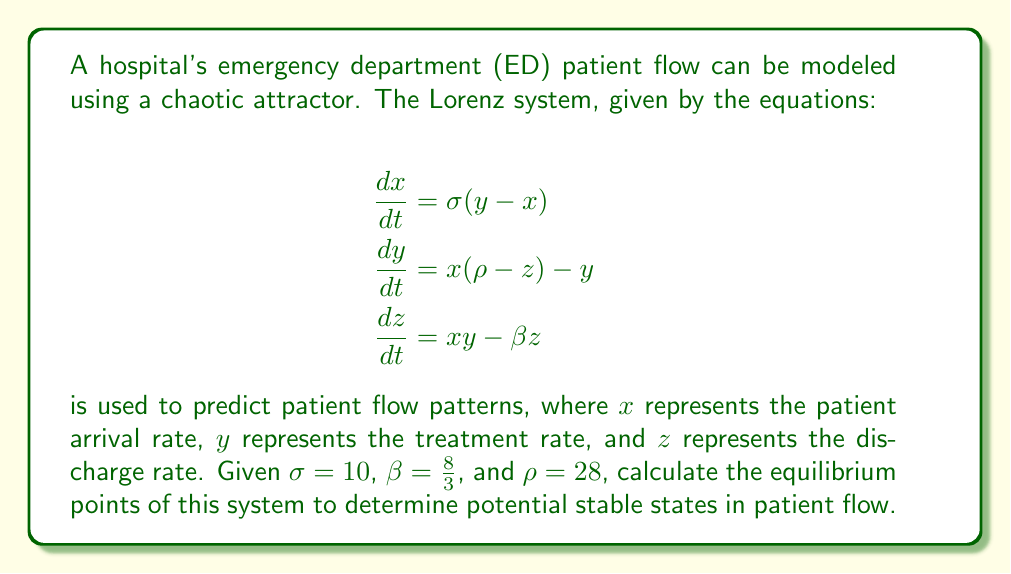Show me your answer to this math problem. To find the equilibrium points, we set all derivatives to zero:

1) $\frac{dx}{dt} = 0$: $\sigma(y - x) = 0$
   This implies $y = x$

2) $\frac{dy}{dt} = 0$: $x(\rho - z) - y = 0$
   Substituting $y = x$: $x(\rho - z) - x = 0$
   $x(\rho - z - 1) = 0$

3) $\frac{dz}{dt} = 0$: $xy - \beta z = 0$
   Substituting $y = x$: $x^2 - \beta z = 0$

From step 2, we have two possibilities:
a) $x = 0$, or
b) $\rho - z - 1 = 0$

Case a) $x = 0$:
If $x = 0$, then $y = 0$ (from step 1), and $z = 0$ (from step 3).
This gives us the first equilibrium point: $(0, 0, 0)$

Case b) $\rho - z - 1 = 0$:
$z = \rho - 1 = 27$

From step 3: $x^2 = \beta z = \frac{8}{3} \cdot 27 = 72$
$x = \pm \sqrt{72} = \pm 6\sqrt{2}$

Since $y = x$, we have two more equilibrium points:
$(\sqrt{72}, \sqrt{72}, 27)$ and $(-\sqrt{72}, -\sqrt{72}, 27)$

Therefore, the three equilibrium points are:
$(0, 0, 0)$, $(6\sqrt{2}, 6\sqrt{2}, 27)$, and $(-6\sqrt{2}, -6\sqrt{2}, 27)$
Answer: $(0, 0, 0)$, $(6\sqrt{2}, 6\sqrt{2}, 27)$, $(-6\sqrt{2}, -6\sqrt{2}, 27)$ 